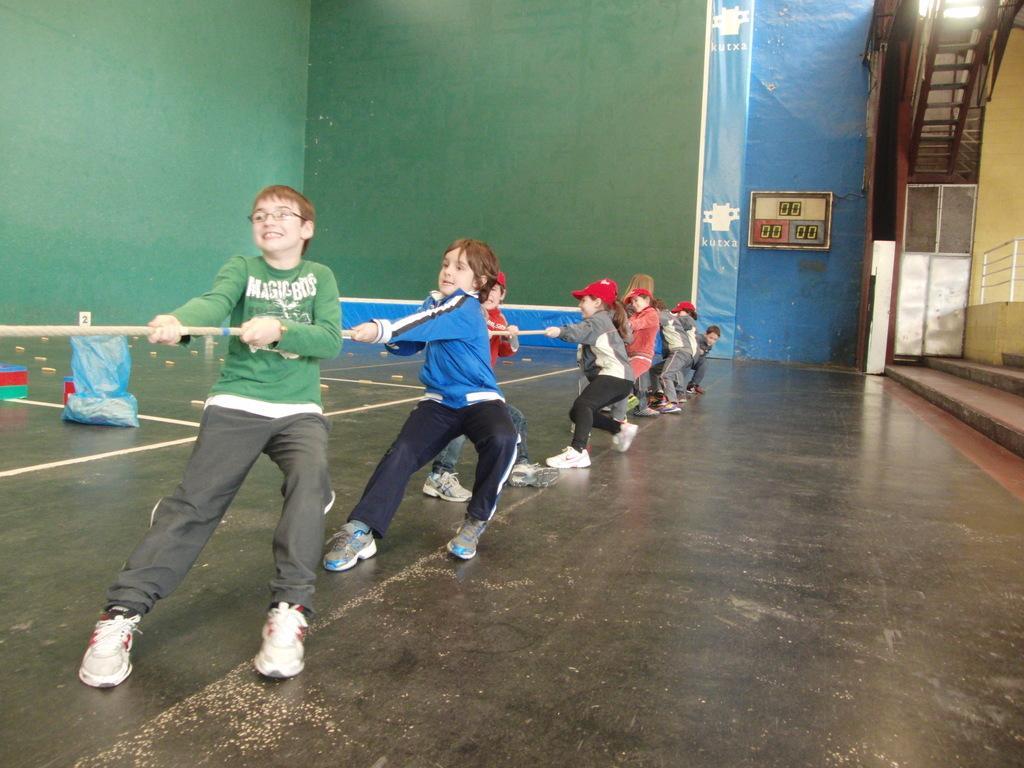In one or two sentences, can you explain what this image depicts? This picture describes about few people, they are holding a rope, beside to them we can find a cover and other things on the floor, in the background we can see a notice board, metal rods and a door. 